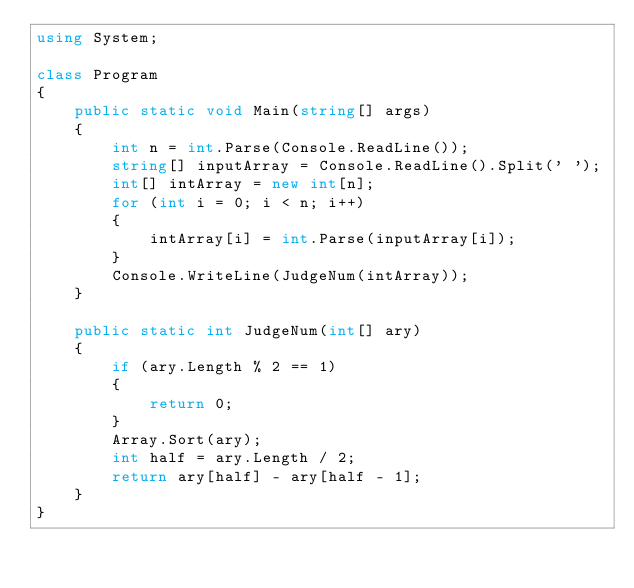Convert code to text. <code><loc_0><loc_0><loc_500><loc_500><_C#_>using System;

class Program
{
    public static void Main(string[] args)
    {
        int n = int.Parse(Console.ReadLine());
        string[] inputArray = Console.ReadLine().Split(' ');
        int[] intArray = new int[n];
        for (int i = 0; i < n; i++)
        {
            intArray[i] = int.Parse(inputArray[i]);
        }
        Console.WriteLine(JudgeNum(intArray));
    }

    public static int JudgeNum(int[] ary)
    {
        if (ary.Length % 2 == 1)
        {
            return 0;
        }
        Array.Sort(ary);
        int half = ary.Length / 2;
        return ary[half] - ary[half - 1];
    }
}</code> 